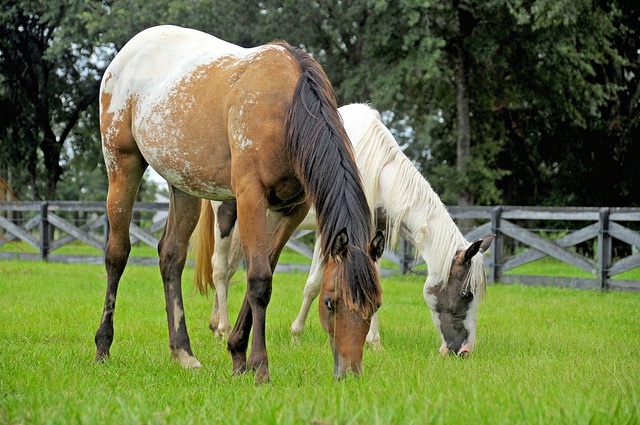Describe the objects in this image and their specific colors. I can see horse in black, gray, tan, and white tones and horse in black, ivory, darkgray, gray, and lightgray tones in this image. 